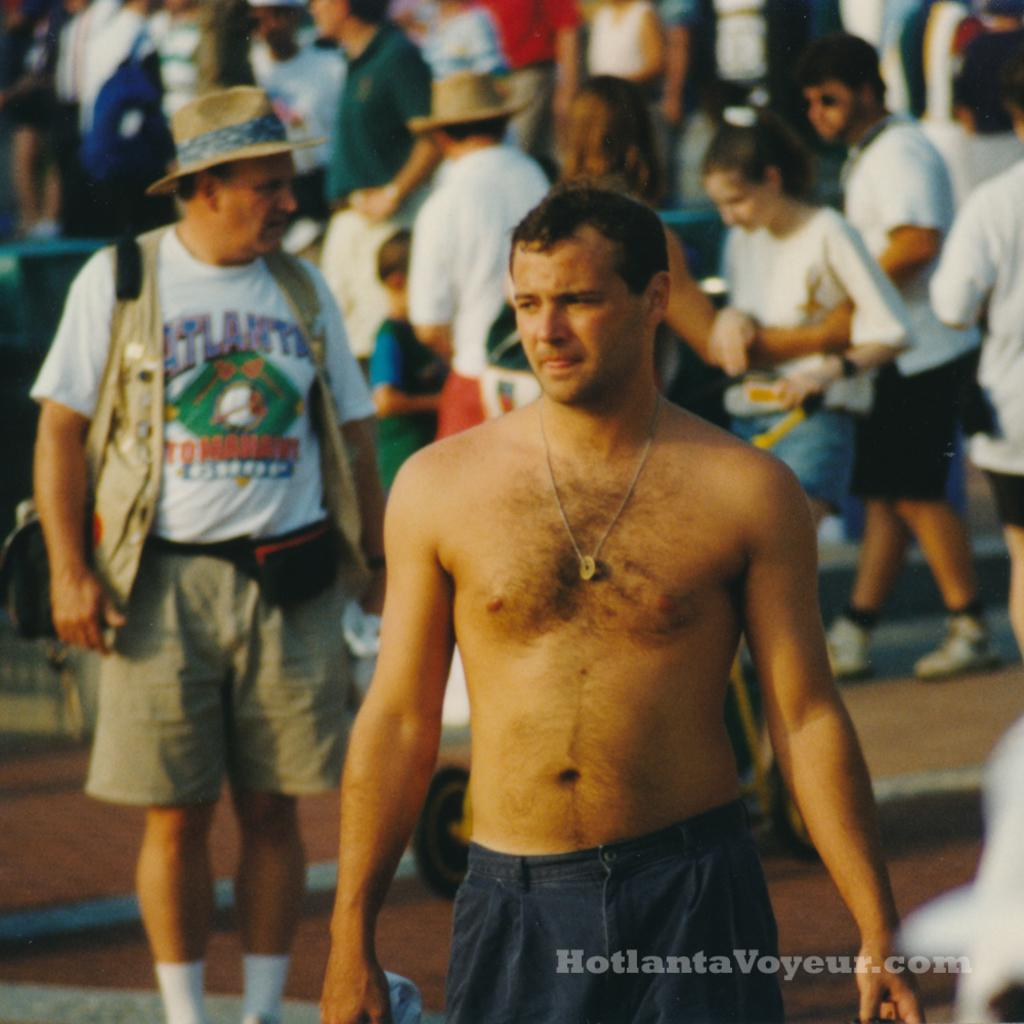<image>
Summarize the visual content of the image. A picture taken by hotlanta voyeur of a man without a shirt on 